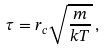Convert formula to latex. <formula><loc_0><loc_0><loc_500><loc_500>\tau = r _ { c } \sqrt { \frac { m } { k T } } \, ,</formula> 